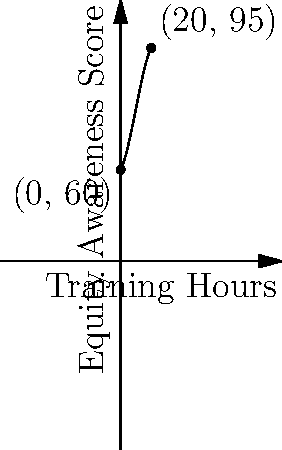As an HR manager implementing equity training, you've modeled the relationship between training hours and equity awareness scores using the polynomial function $f(x) = -0.01x^3 + 0.3x^2 + 2x + 60$, where $x$ is the number of training hours and $f(x)$ is the equity awareness score. Based on the graph, what is the maximum equity awareness score that can be achieved, and how many training hours are required to reach this maximum? To find the maximum equity awareness score and the corresponding number of training hours, we need to follow these steps:

1) First, we need to find the derivative of the function:
   $f'(x) = -0.03x^2 + 0.6x + 2$

2) To find the maximum, we set the derivative to zero and solve for x:
   $-0.03x^2 + 0.6x + 2 = 0$

3) This is a quadratic equation. We can solve it using the quadratic formula:
   $x = \frac{-b \pm \sqrt{b^2 - 4ac}}{2a}$

   Where $a = -0.03$, $b = 0.6$, and $c = 2$

4) Plugging in these values:
   $x = \frac{-0.6 \pm \sqrt{0.6^2 - 4(-0.03)(2)}}{2(-0.03)}$

5) Solving this:
   $x \approx 10$ or $x \approx 6.67$

6) The positive solution that makes sense in our context is $x \approx 10$.

7) To find the maximum score, we plug this value back into our original function:
   $f(10) = -0.01(10)^3 + 0.3(10)^2 + 2(10) + 60 \approx 95.5$

Therefore, the maximum equity awareness score is approximately 95.5, achieved after 10 hours of training.
Answer: Maximum score: 95.5, achieved at 10 training hours 